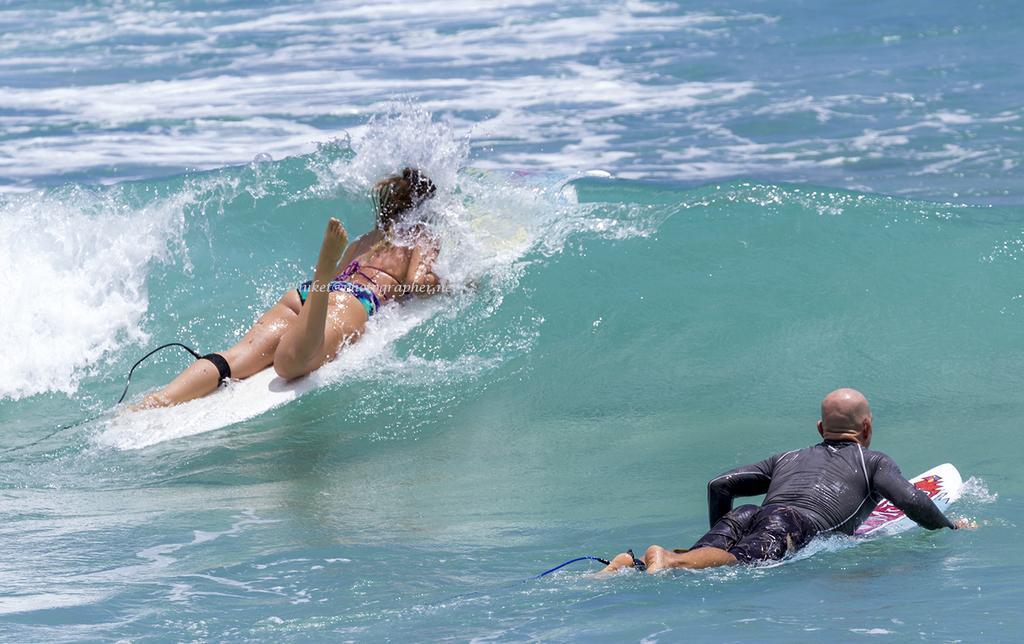Please provide a concise description of this image. In this image I can see a woman and a man on surfing board. I can see water and water wave. 